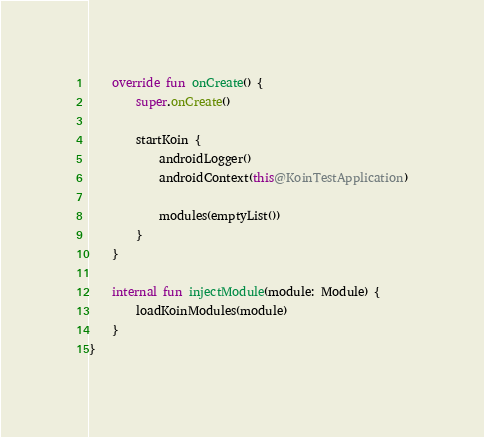Convert code to text. <code><loc_0><loc_0><loc_500><loc_500><_Kotlin_>    override fun onCreate() {
        super.onCreate()

        startKoin {
            androidLogger()
            androidContext(this@KoinTestApplication)

            modules(emptyList())
        }
    }

    internal fun injectModule(module: Module) {
        loadKoinModules(module)
    }
}</code> 